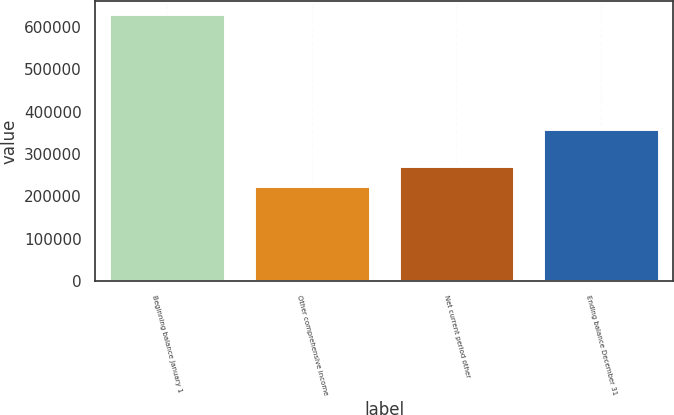Convert chart. <chart><loc_0><loc_0><loc_500><loc_500><bar_chart><fcel>Beginning balance January 1<fcel>Other comprehensive income<fcel>Net current period other<fcel>Ending balance December 31<nl><fcel>629907<fcel>223991<fcel>270828<fcel>359079<nl></chart> 